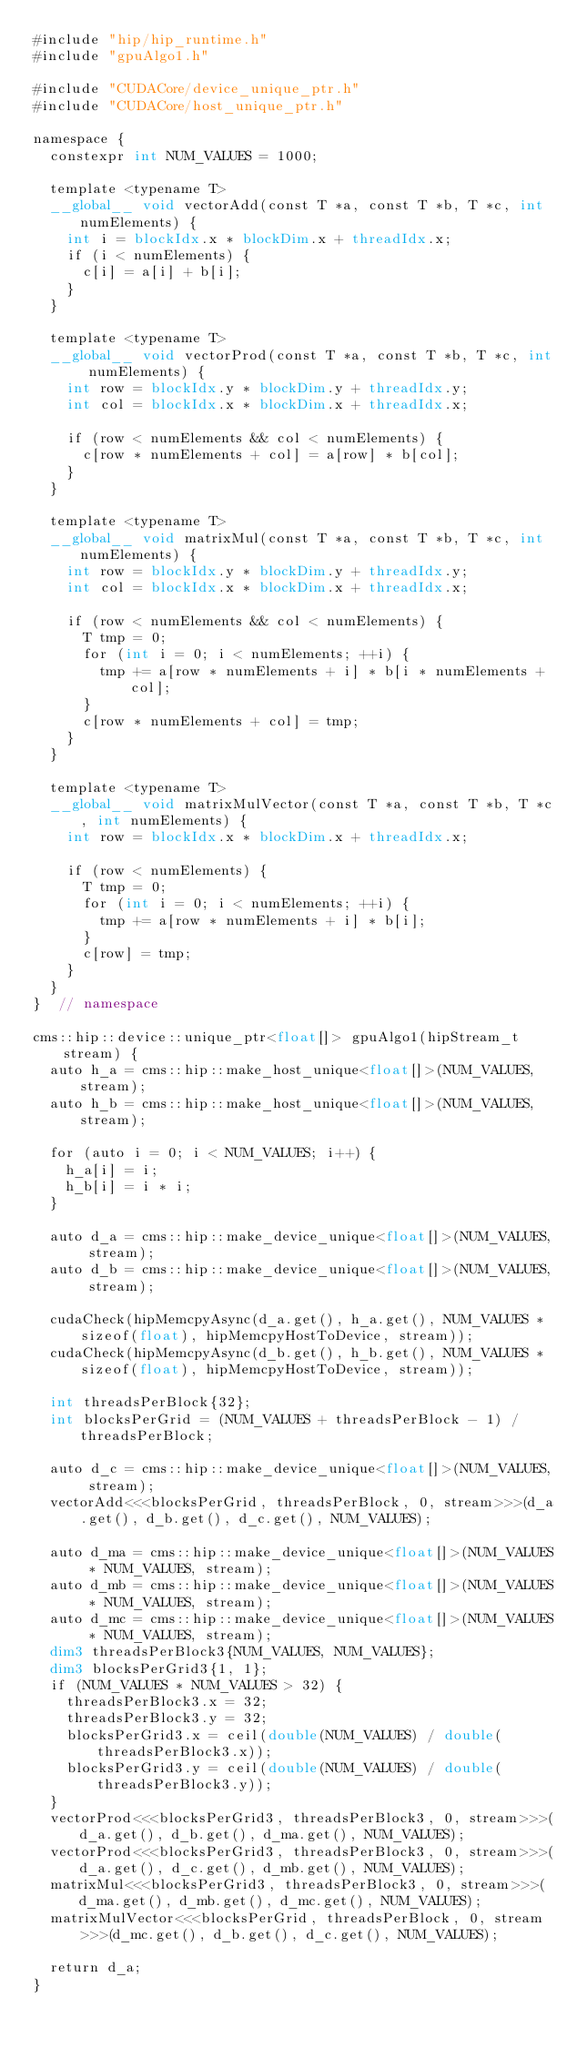<code> <loc_0><loc_0><loc_500><loc_500><_Cuda_>#include "hip/hip_runtime.h"
#include "gpuAlgo1.h"

#include "CUDACore/device_unique_ptr.h"
#include "CUDACore/host_unique_ptr.h"

namespace {
  constexpr int NUM_VALUES = 1000;

  template <typename T>
  __global__ void vectorAdd(const T *a, const T *b, T *c, int numElements) {
    int i = blockIdx.x * blockDim.x + threadIdx.x;
    if (i < numElements) {
      c[i] = a[i] + b[i];
    }
  }

  template <typename T>
  __global__ void vectorProd(const T *a, const T *b, T *c, int numElements) {
    int row = blockIdx.y * blockDim.y + threadIdx.y;
    int col = blockIdx.x * blockDim.x + threadIdx.x;

    if (row < numElements && col < numElements) {
      c[row * numElements + col] = a[row] * b[col];
    }
  }

  template <typename T>
  __global__ void matrixMul(const T *a, const T *b, T *c, int numElements) {
    int row = blockIdx.y * blockDim.y + threadIdx.y;
    int col = blockIdx.x * blockDim.x + threadIdx.x;

    if (row < numElements && col < numElements) {
      T tmp = 0;
      for (int i = 0; i < numElements; ++i) {
        tmp += a[row * numElements + i] * b[i * numElements + col];
      }
      c[row * numElements + col] = tmp;
    }
  }

  template <typename T>
  __global__ void matrixMulVector(const T *a, const T *b, T *c, int numElements) {
    int row = blockIdx.x * blockDim.x + threadIdx.x;

    if (row < numElements) {
      T tmp = 0;
      for (int i = 0; i < numElements; ++i) {
        tmp += a[row * numElements + i] * b[i];
      }
      c[row] = tmp;
    }
  }
}  // namespace

cms::hip::device::unique_ptr<float[]> gpuAlgo1(hipStream_t stream) {
  auto h_a = cms::hip::make_host_unique<float[]>(NUM_VALUES, stream);
  auto h_b = cms::hip::make_host_unique<float[]>(NUM_VALUES, stream);

  for (auto i = 0; i < NUM_VALUES; i++) {
    h_a[i] = i;
    h_b[i] = i * i;
  }

  auto d_a = cms::hip::make_device_unique<float[]>(NUM_VALUES, stream);
  auto d_b = cms::hip::make_device_unique<float[]>(NUM_VALUES, stream);

  cudaCheck(hipMemcpyAsync(d_a.get(), h_a.get(), NUM_VALUES * sizeof(float), hipMemcpyHostToDevice, stream));
  cudaCheck(hipMemcpyAsync(d_b.get(), h_b.get(), NUM_VALUES * sizeof(float), hipMemcpyHostToDevice, stream));

  int threadsPerBlock{32};
  int blocksPerGrid = (NUM_VALUES + threadsPerBlock - 1) / threadsPerBlock;

  auto d_c = cms::hip::make_device_unique<float[]>(NUM_VALUES, stream);
  vectorAdd<<<blocksPerGrid, threadsPerBlock, 0, stream>>>(d_a.get(), d_b.get(), d_c.get(), NUM_VALUES);

  auto d_ma = cms::hip::make_device_unique<float[]>(NUM_VALUES * NUM_VALUES, stream);
  auto d_mb = cms::hip::make_device_unique<float[]>(NUM_VALUES * NUM_VALUES, stream);
  auto d_mc = cms::hip::make_device_unique<float[]>(NUM_VALUES * NUM_VALUES, stream);
  dim3 threadsPerBlock3{NUM_VALUES, NUM_VALUES};
  dim3 blocksPerGrid3{1, 1};
  if (NUM_VALUES * NUM_VALUES > 32) {
    threadsPerBlock3.x = 32;
    threadsPerBlock3.y = 32;
    blocksPerGrid3.x = ceil(double(NUM_VALUES) / double(threadsPerBlock3.x));
    blocksPerGrid3.y = ceil(double(NUM_VALUES) / double(threadsPerBlock3.y));
  }
  vectorProd<<<blocksPerGrid3, threadsPerBlock3, 0, stream>>>(d_a.get(), d_b.get(), d_ma.get(), NUM_VALUES);
  vectorProd<<<blocksPerGrid3, threadsPerBlock3, 0, stream>>>(d_a.get(), d_c.get(), d_mb.get(), NUM_VALUES);
  matrixMul<<<blocksPerGrid3, threadsPerBlock3, 0, stream>>>(d_ma.get(), d_mb.get(), d_mc.get(), NUM_VALUES);
  matrixMulVector<<<blocksPerGrid, threadsPerBlock, 0, stream>>>(d_mc.get(), d_b.get(), d_c.get(), NUM_VALUES);

  return d_a;
}
</code> 